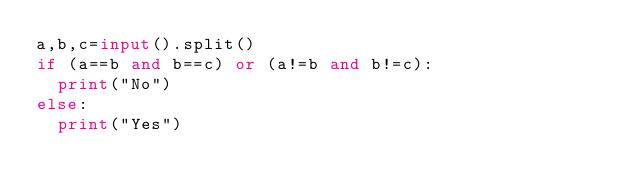Convert code to text. <code><loc_0><loc_0><loc_500><loc_500><_Python_>a,b,c=input().split()
if (a==b and b==c) or (a!=b and b!=c):
  print("No")
else:
  print("Yes")</code> 